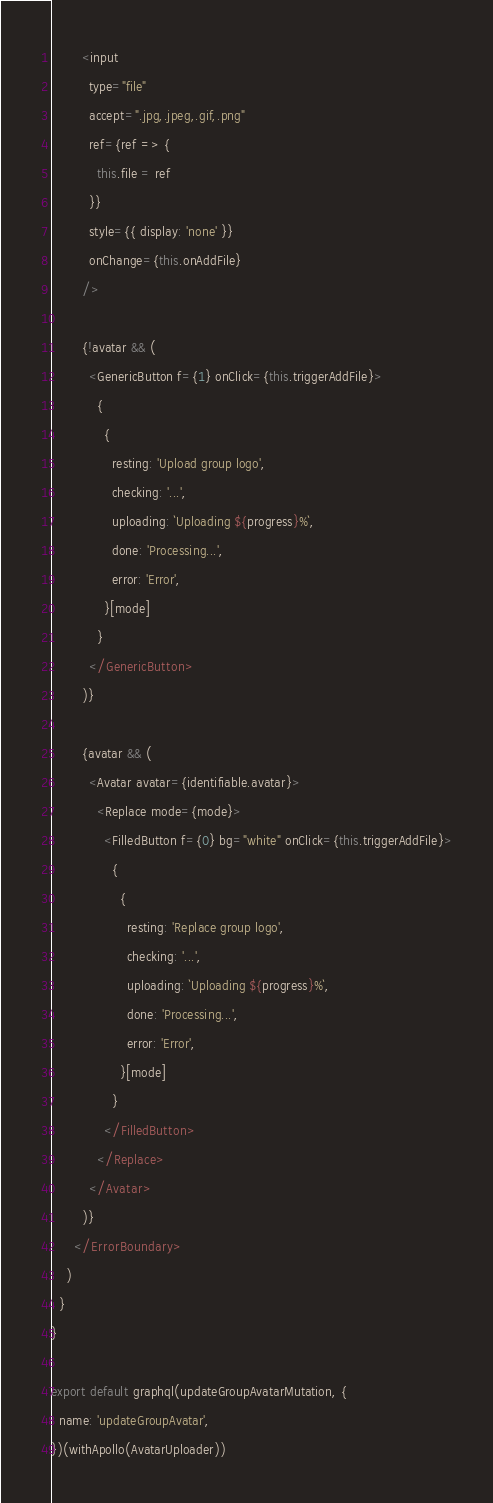Convert code to text. <code><loc_0><loc_0><loc_500><loc_500><_JavaScript_>        <input
          type="file"
          accept=".jpg,.jpeg,.gif,.png"
          ref={ref => {
            this.file = ref
          }}
          style={{ display: 'none' }}
          onChange={this.onAddFile}
        />

        {!avatar && (
          <GenericButton f={1} onClick={this.triggerAddFile}>
            {
              {
                resting: 'Upload group logo',
                checking: '...',
                uploading: `Uploading ${progress}%`,
                done: 'Processing...',
                error: 'Error',
              }[mode]
            }
          </GenericButton>
        )}

        {avatar && (
          <Avatar avatar={identifiable.avatar}>
            <Replace mode={mode}>
              <FilledButton f={0} bg="white" onClick={this.triggerAddFile}>
                {
                  {
                    resting: 'Replace group logo',
                    checking: '...',
                    uploading: `Uploading ${progress}%`,
                    done: 'Processing...',
                    error: 'Error',
                  }[mode]
                }
              </FilledButton>
            </Replace>
          </Avatar>
        )}
      </ErrorBoundary>
    )
  }
}

export default graphql(updateGroupAvatarMutation, {
  name: 'updateGroupAvatar',
})(withApollo(AvatarUploader))
</code> 